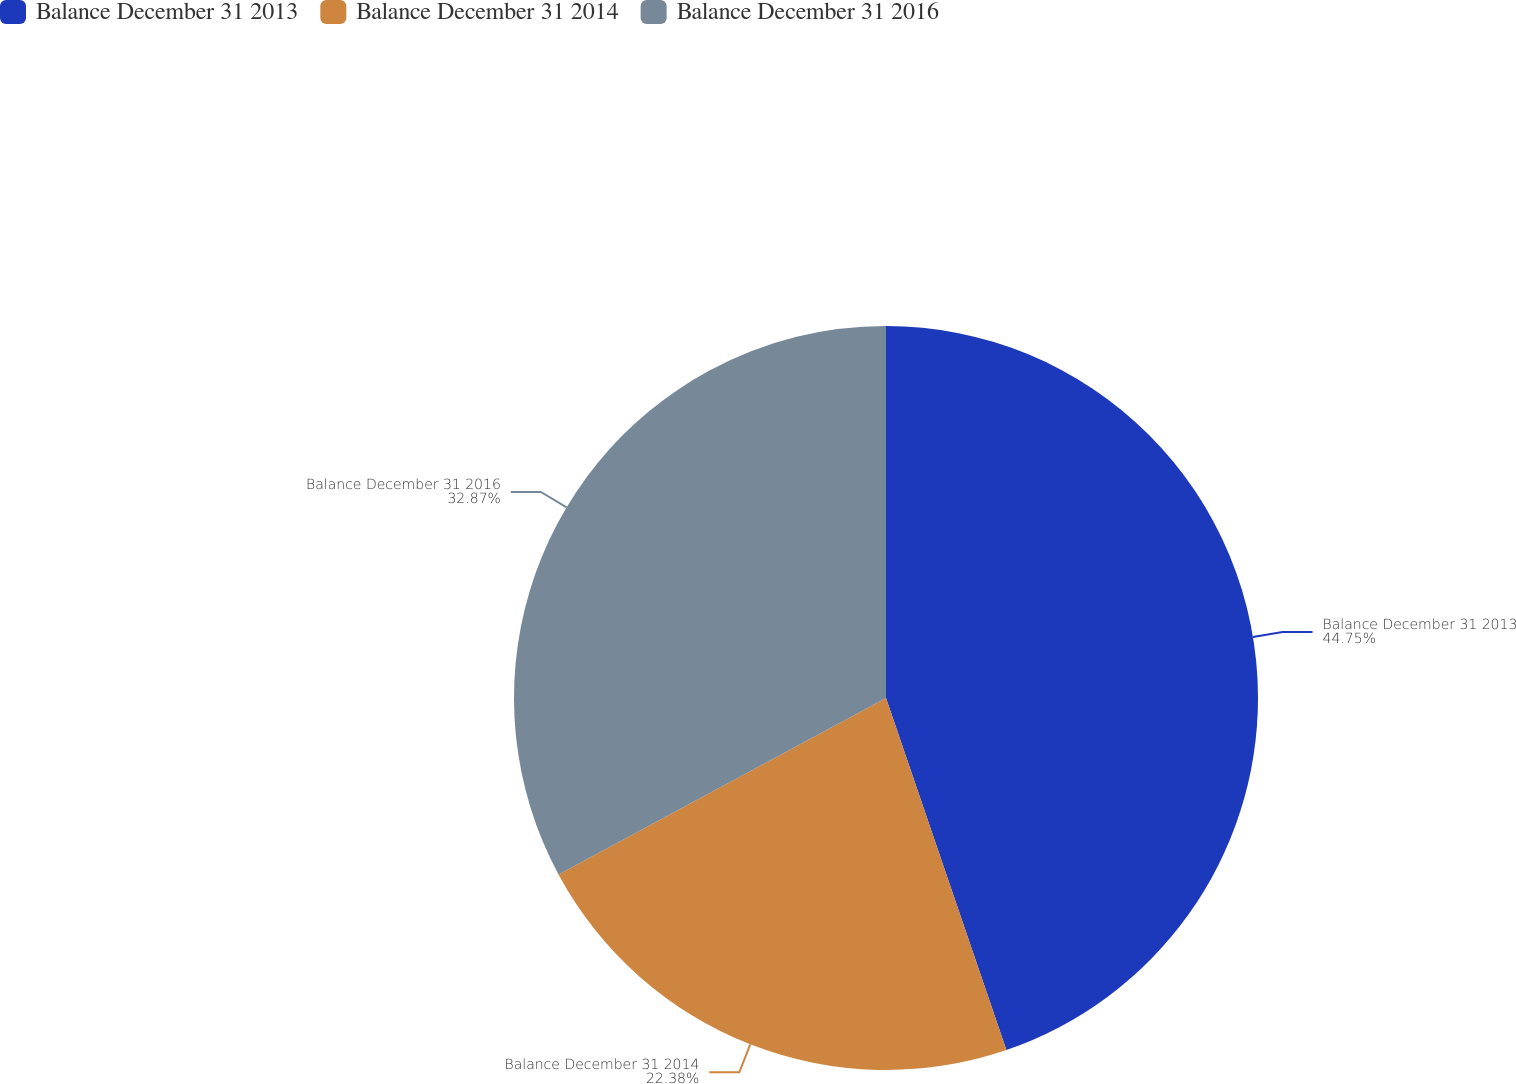<chart> <loc_0><loc_0><loc_500><loc_500><pie_chart><fcel>Balance December 31 2013<fcel>Balance December 31 2014<fcel>Balance December 31 2016<nl><fcel>44.76%<fcel>22.38%<fcel>32.87%<nl></chart> 